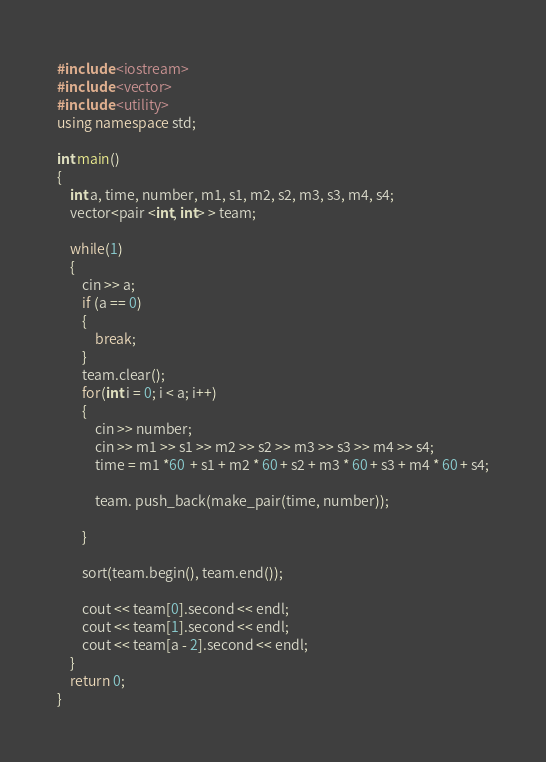Convert code to text. <code><loc_0><loc_0><loc_500><loc_500><_C++_>#include <iostream>
#include <vector>
#include <utility>
using namespace std;

int main()
{
	int a, time, number, m1, s1, m2, s2, m3, s3, m4, s4;
	vector<pair <int, int> > team;
	
	while(1)
	{
		cin >> a;
		if (a == 0)
		{
			break;
		}
		team.clear();
		for(int i = 0; i < a; i++)
		{
			cin >> number;
			cin >> m1 >> s1 >> m2 >> s2 >> m3 >> s3 >> m4 >> s4;
			time = m1 *60  + s1 + m2 * 60 + s2 + m3 * 60 + s3 + m4 * 60 + s4;
		
			team. push_back(make_pair(time, number));
		
		}
	
		sort(team.begin(), team.end());
	
		cout << team[0].second << endl;
		cout << team[1].second << endl;
		cout << team[a - 2].second << endl;
	}
	return 0;
}</code> 